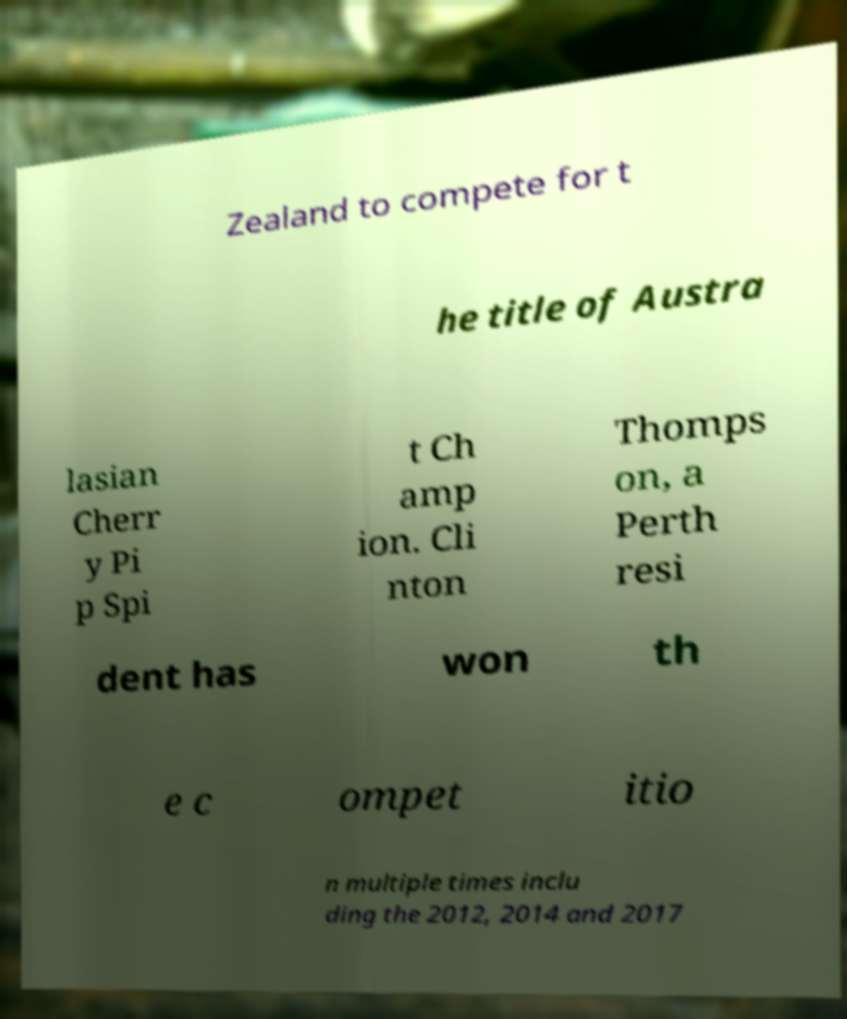Please read and relay the text visible in this image. What does it say? Zealand to compete for t he title of Austra lasian Cherr y Pi p Spi t Ch amp ion. Cli nton Thomps on, a Perth resi dent has won th e c ompet itio n multiple times inclu ding the 2012, 2014 and 2017 